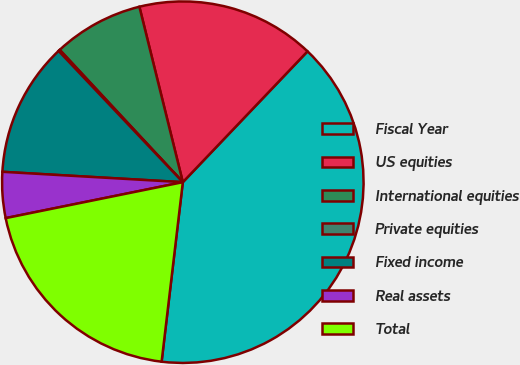Convert chart to OTSL. <chart><loc_0><loc_0><loc_500><loc_500><pie_chart><fcel>Fiscal Year<fcel>US equities<fcel>International equities<fcel>Private equities<fcel>Fixed income<fcel>Real assets<fcel>Total<nl><fcel>39.75%<fcel>15.98%<fcel>8.06%<fcel>0.14%<fcel>12.02%<fcel>4.1%<fcel>19.94%<nl></chart> 